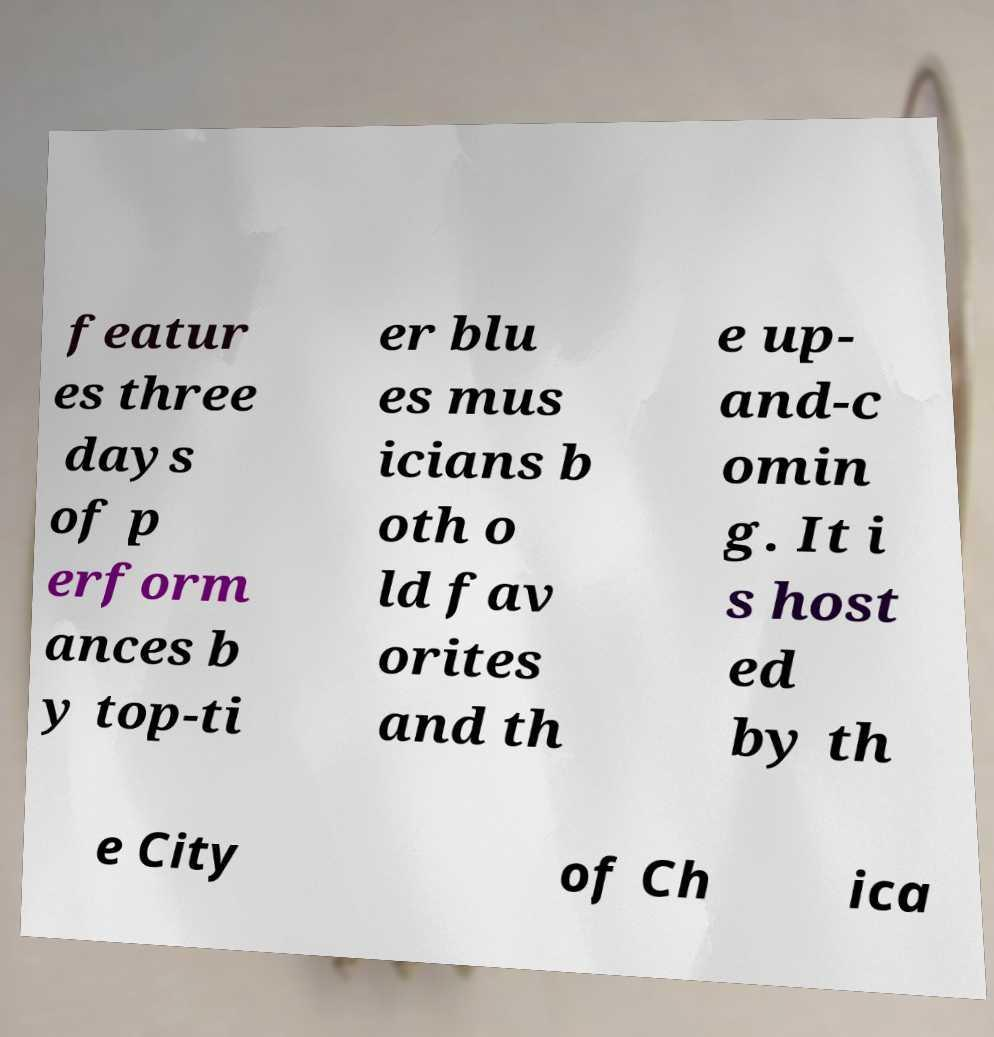I need the written content from this picture converted into text. Can you do that? featur es three days of p erform ances b y top-ti er blu es mus icians b oth o ld fav orites and th e up- and-c omin g. It i s host ed by th e City of Ch ica 